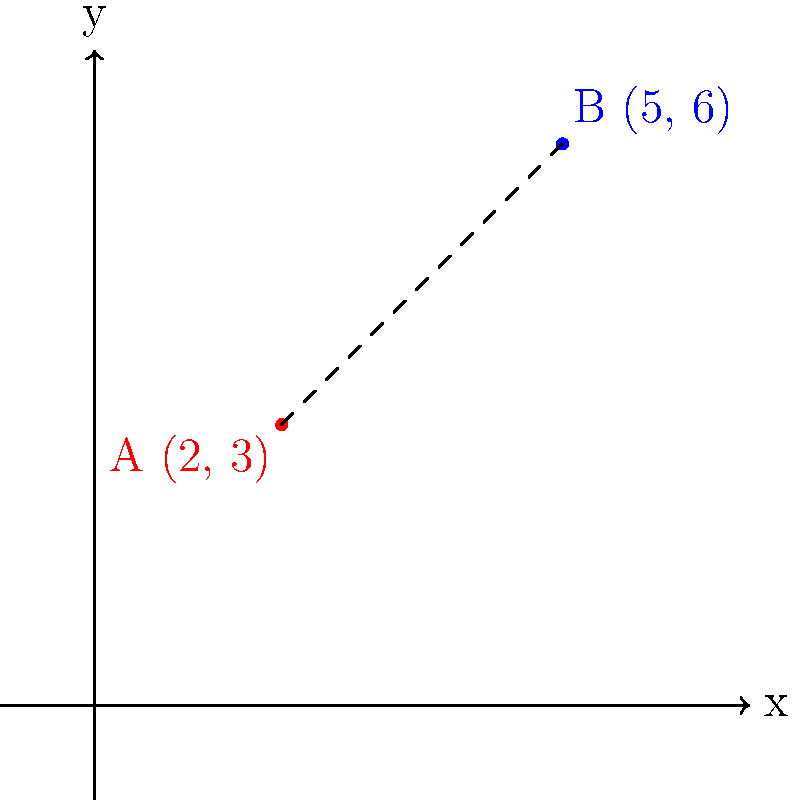In your cat grooming studio, you're planning the layout of two grooming stations. On the floor plan, station A is located at coordinates (2, 3) and station B is at (5, 6). What is the distance between these two stations? To find the distance between two points in a coordinate plane, we can use the distance formula, which is derived from the Pythagorean theorem:

$$d = \sqrt{(x_2 - x_1)^2 + (y_2 - y_1)^2}$$

Where $(x_1, y_1)$ are the coordinates of the first point and $(x_2, y_2)$ are the coordinates of the second point.

Let's solve this step-by-step:

1) Identify the coordinates:
   Point A: $(x_1, y_1) = (2, 3)$
   Point B: $(x_2, y_2) = (5, 6)$

2) Plug these values into the distance formula:
   $$d = \sqrt{(5 - 2)^2 + (6 - 3)^2}$$

3) Simplify inside the parentheses:
   $$d = \sqrt{3^2 + 3^2}$$

4) Calculate the squares:
   $$d = \sqrt{9 + 9}$$

5) Add inside the square root:
   $$d = \sqrt{18}$$

6) Simplify the square root:
   $$d = 3\sqrt{2}$$

Therefore, the distance between the two grooming stations is $3\sqrt{2}$ units.
Answer: $3\sqrt{2}$ units 